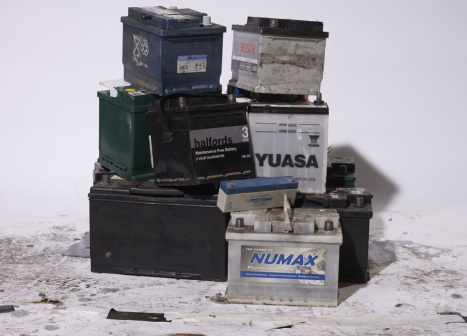Describe the potential environmental impacts of the scene depicted in the image. The image shows a pile of old car batteries, potentially exposing the environment to harmful substances. Improperly disposed batteries can leak acid and heavy metals, like lead and cadmium, into the soil and groundwater. This contamination can harm plants, animals, and even humans if it enters the food chain. Proper recycling and disposal practices are crucial to mitigate these risks and ensure environmental safety. 